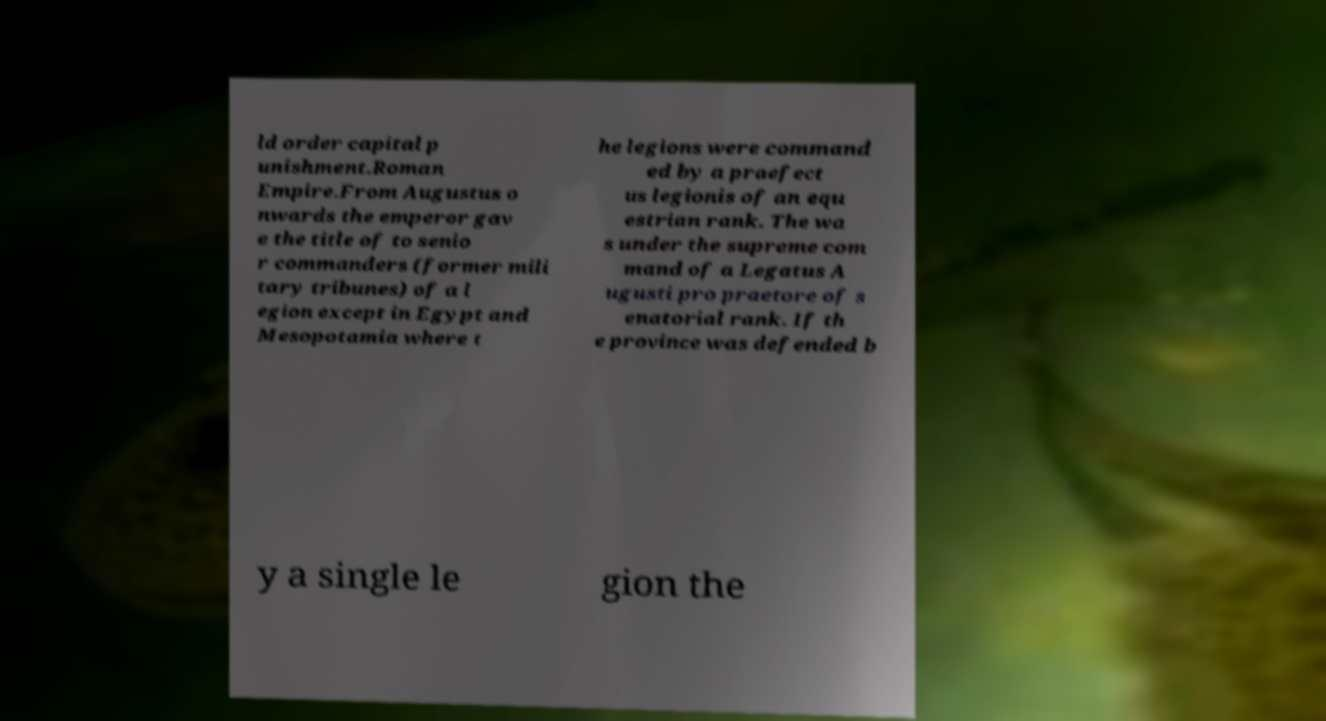What messages or text are displayed in this image? I need them in a readable, typed format. ld order capital p unishment.Roman Empire.From Augustus o nwards the emperor gav e the title of to senio r commanders (former mili tary tribunes) of a l egion except in Egypt and Mesopotamia where t he legions were command ed by a praefect us legionis of an equ estrian rank. The wa s under the supreme com mand of a Legatus A ugusti pro praetore of s enatorial rank. If th e province was defended b y a single le gion the 